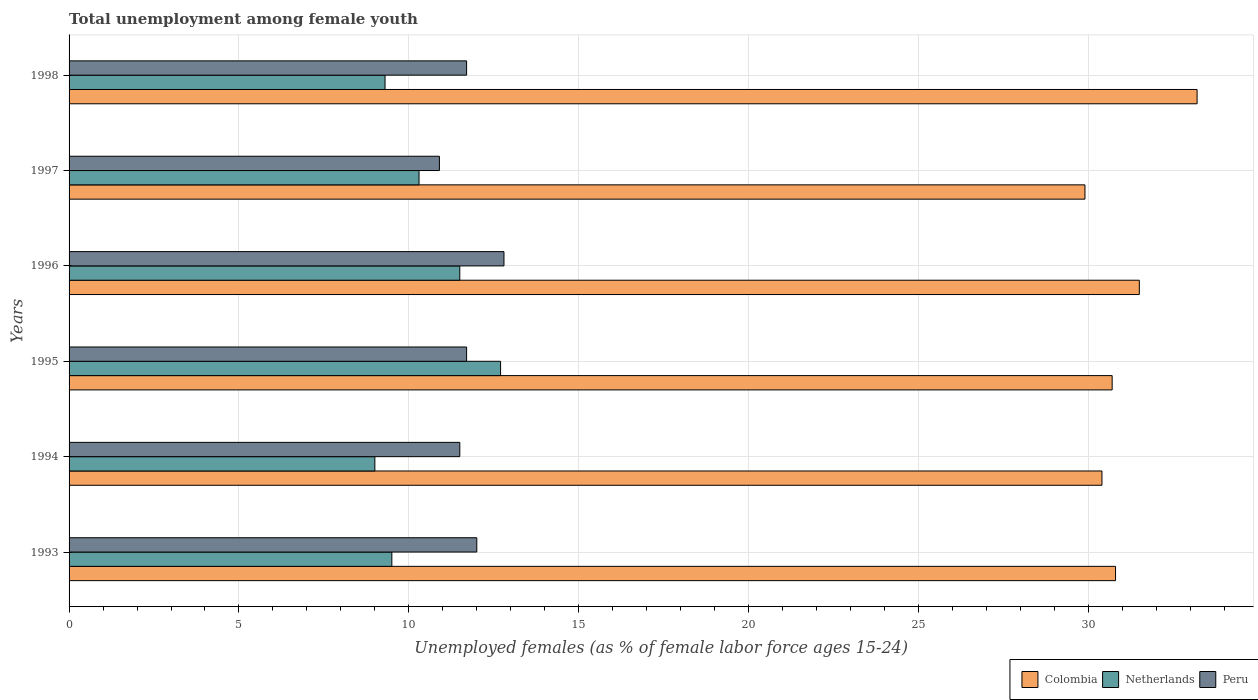How many different coloured bars are there?
Give a very brief answer. 3. Are the number of bars on each tick of the Y-axis equal?
Your answer should be very brief. Yes. How many bars are there on the 5th tick from the bottom?
Make the answer very short. 3. What is the percentage of unemployed females in in Peru in 1993?
Provide a succinct answer. 12. Across all years, what is the maximum percentage of unemployed females in in Colombia?
Provide a short and direct response. 33.2. Across all years, what is the minimum percentage of unemployed females in in Peru?
Offer a terse response. 10.9. In which year was the percentage of unemployed females in in Colombia minimum?
Your answer should be very brief. 1997. What is the total percentage of unemployed females in in Peru in the graph?
Offer a terse response. 70.6. What is the difference between the percentage of unemployed females in in Netherlands in 1994 and that in 1995?
Ensure brevity in your answer.  -3.7. What is the difference between the percentage of unemployed females in in Colombia in 1994 and the percentage of unemployed females in in Netherlands in 1995?
Your answer should be very brief. 17.7. What is the average percentage of unemployed females in in Colombia per year?
Offer a very short reply. 31.08. In the year 1997, what is the difference between the percentage of unemployed females in in Peru and percentage of unemployed females in in Colombia?
Your answer should be very brief. -19. What is the ratio of the percentage of unemployed females in in Netherlands in 1997 to that in 1998?
Ensure brevity in your answer.  1.11. Is the percentage of unemployed females in in Netherlands in 1995 less than that in 1996?
Your answer should be compact. No. Is the difference between the percentage of unemployed females in in Peru in 1995 and 1998 greater than the difference between the percentage of unemployed females in in Colombia in 1995 and 1998?
Make the answer very short. Yes. What is the difference between the highest and the second highest percentage of unemployed females in in Netherlands?
Ensure brevity in your answer.  1.2. What is the difference between the highest and the lowest percentage of unemployed females in in Colombia?
Make the answer very short. 3.3. In how many years, is the percentage of unemployed females in in Netherlands greater than the average percentage of unemployed females in in Netherlands taken over all years?
Your response must be concise. 2. Is the sum of the percentage of unemployed females in in Colombia in 1995 and 1997 greater than the maximum percentage of unemployed females in in Netherlands across all years?
Make the answer very short. Yes. Is it the case that in every year, the sum of the percentage of unemployed females in in Colombia and percentage of unemployed females in in Netherlands is greater than the percentage of unemployed females in in Peru?
Your answer should be very brief. Yes. How many bars are there?
Make the answer very short. 18. Are the values on the major ticks of X-axis written in scientific E-notation?
Your response must be concise. No. Does the graph contain grids?
Your answer should be compact. Yes. Where does the legend appear in the graph?
Provide a succinct answer. Bottom right. What is the title of the graph?
Give a very brief answer. Total unemployment among female youth. What is the label or title of the X-axis?
Your answer should be compact. Unemployed females (as % of female labor force ages 15-24). What is the label or title of the Y-axis?
Provide a short and direct response. Years. What is the Unemployed females (as % of female labor force ages 15-24) in Colombia in 1993?
Provide a short and direct response. 30.8. What is the Unemployed females (as % of female labor force ages 15-24) in Netherlands in 1993?
Give a very brief answer. 9.5. What is the Unemployed females (as % of female labor force ages 15-24) in Peru in 1993?
Provide a short and direct response. 12. What is the Unemployed females (as % of female labor force ages 15-24) of Colombia in 1994?
Offer a very short reply. 30.4. What is the Unemployed females (as % of female labor force ages 15-24) in Peru in 1994?
Ensure brevity in your answer.  11.5. What is the Unemployed females (as % of female labor force ages 15-24) of Colombia in 1995?
Give a very brief answer. 30.7. What is the Unemployed females (as % of female labor force ages 15-24) in Netherlands in 1995?
Your response must be concise. 12.7. What is the Unemployed females (as % of female labor force ages 15-24) in Peru in 1995?
Your answer should be compact. 11.7. What is the Unemployed females (as % of female labor force ages 15-24) in Colombia in 1996?
Ensure brevity in your answer.  31.5. What is the Unemployed females (as % of female labor force ages 15-24) of Netherlands in 1996?
Provide a short and direct response. 11.5. What is the Unemployed females (as % of female labor force ages 15-24) of Peru in 1996?
Keep it short and to the point. 12.8. What is the Unemployed females (as % of female labor force ages 15-24) of Colombia in 1997?
Your answer should be compact. 29.9. What is the Unemployed females (as % of female labor force ages 15-24) of Netherlands in 1997?
Your answer should be very brief. 10.3. What is the Unemployed females (as % of female labor force ages 15-24) of Peru in 1997?
Provide a short and direct response. 10.9. What is the Unemployed females (as % of female labor force ages 15-24) in Colombia in 1998?
Make the answer very short. 33.2. What is the Unemployed females (as % of female labor force ages 15-24) of Netherlands in 1998?
Give a very brief answer. 9.3. What is the Unemployed females (as % of female labor force ages 15-24) of Peru in 1998?
Keep it short and to the point. 11.7. Across all years, what is the maximum Unemployed females (as % of female labor force ages 15-24) of Colombia?
Your answer should be compact. 33.2. Across all years, what is the maximum Unemployed females (as % of female labor force ages 15-24) in Netherlands?
Your answer should be compact. 12.7. Across all years, what is the maximum Unemployed females (as % of female labor force ages 15-24) in Peru?
Offer a very short reply. 12.8. Across all years, what is the minimum Unemployed females (as % of female labor force ages 15-24) of Colombia?
Offer a terse response. 29.9. Across all years, what is the minimum Unemployed females (as % of female labor force ages 15-24) in Peru?
Your answer should be very brief. 10.9. What is the total Unemployed females (as % of female labor force ages 15-24) in Colombia in the graph?
Your answer should be compact. 186.5. What is the total Unemployed females (as % of female labor force ages 15-24) in Netherlands in the graph?
Your answer should be very brief. 62.3. What is the total Unemployed females (as % of female labor force ages 15-24) in Peru in the graph?
Ensure brevity in your answer.  70.6. What is the difference between the Unemployed females (as % of female labor force ages 15-24) in Colombia in 1993 and that in 1995?
Keep it short and to the point. 0.1. What is the difference between the Unemployed females (as % of female labor force ages 15-24) of Peru in 1993 and that in 1995?
Your answer should be very brief. 0.3. What is the difference between the Unemployed females (as % of female labor force ages 15-24) of Colombia in 1993 and that in 1996?
Offer a very short reply. -0.7. What is the difference between the Unemployed females (as % of female labor force ages 15-24) of Colombia in 1993 and that in 1997?
Offer a terse response. 0.9. What is the difference between the Unemployed females (as % of female labor force ages 15-24) of Colombia in 1993 and that in 1998?
Offer a very short reply. -2.4. What is the difference between the Unemployed females (as % of female labor force ages 15-24) in Netherlands in 1993 and that in 1998?
Your answer should be very brief. 0.2. What is the difference between the Unemployed females (as % of female labor force ages 15-24) of Peru in 1993 and that in 1998?
Offer a very short reply. 0.3. What is the difference between the Unemployed females (as % of female labor force ages 15-24) in Peru in 1994 and that in 1995?
Your answer should be compact. -0.2. What is the difference between the Unemployed females (as % of female labor force ages 15-24) in Colombia in 1994 and that in 1997?
Provide a short and direct response. 0.5. What is the difference between the Unemployed females (as % of female labor force ages 15-24) of Netherlands in 1994 and that in 1997?
Provide a short and direct response. -1.3. What is the difference between the Unemployed females (as % of female labor force ages 15-24) of Peru in 1994 and that in 1997?
Your answer should be very brief. 0.6. What is the difference between the Unemployed females (as % of female labor force ages 15-24) of Netherlands in 1994 and that in 1998?
Offer a terse response. -0.3. What is the difference between the Unemployed females (as % of female labor force ages 15-24) of Peru in 1994 and that in 1998?
Your answer should be very brief. -0.2. What is the difference between the Unemployed females (as % of female labor force ages 15-24) in Netherlands in 1995 and that in 1996?
Keep it short and to the point. 1.2. What is the difference between the Unemployed females (as % of female labor force ages 15-24) of Peru in 1995 and that in 1996?
Your answer should be compact. -1.1. What is the difference between the Unemployed females (as % of female labor force ages 15-24) of Colombia in 1995 and that in 1997?
Ensure brevity in your answer.  0.8. What is the difference between the Unemployed females (as % of female labor force ages 15-24) of Colombia in 1995 and that in 1998?
Your answer should be compact. -2.5. What is the difference between the Unemployed females (as % of female labor force ages 15-24) in Colombia in 1996 and that in 1997?
Your answer should be compact. 1.6. What is the difference between the Unemployed females (as % of female labor force ages 15-24) in Peru in 1996 and that in 1997?
Give a very brief answer. 1.9. What is the difference between the Unemployed females (as % of female labor force ages 15-24) of Colombia in 1996 and that in 1998?
Provide a short and direct response. -1.7. What is the difference between the Unemployed females (as % of female labor force ages 15-24) of Peru in 1996 and that in 1998?
Offer a terse response. 1.1. What is the difference between the Unemployed females (as % of female labor force ages 15-24) of Colombia in 1997 and that in 1998?
Make the answer very short. -3.3. What is the difference between the Unemployed females (as % of female labor force ages 15-24) in Netherlands in 1997 and that in 1998?
Your answer should be compact. 1. What is the difference between the Unemployed females (as % of female labor force ages 15-24) in Peru in 1997 and that in 1998?
Offer a very short reply. -0.8. What is the difference between the Unemployed females (as % of female labor force ages 15-24) of Colombia in 1993 and the Unemployed females (as % of female labor force ages 15-24) of Netherlands in 1994?
Make the answer very short. 21.8. What is the difference between the Unemployed females (as % of female labor force ages 15-24) in Colombia in 1993 and the Unemployed females (as % of female labor force ages 15-24) in Peru in 1994?
Your answer should be very brief. 19.3. What is the difference between the Unemployed females (as % of female labor force ages 15-24) in Colombia in 1993 and the Unemployed females (as % of female labor force ages 15-24) in Peru in 1995?
Offer a very short reply. 19.1. What is the difference between the Unemployed females (as % of female labor force ages 15-24) of Colombia in 1993 and the Unemployed females (as % of female labor force ages 15-24) of Netherlands in 1996?
Your answer should be very brief. 19.3. What is the difference between the Unemployed females (as % of female labor force ages 15-24) of Colombia in 1993 and the Unemployed females (as % of female labor force ages 15-24) of Peru in 1996?
Keep it short and to the point. 18. What is the difference between the Unemployed females (as % of female labor force ages 15-24) of Colombia in 1993 and the Unemployed females (as % of female labor force ages 15-24) of Peru in 1998?
Your response must be concise. 19.1. What is the difference between the Unemployed females (as % of female labor force ages 15-24) of Netherlands in 1993 and the Unemployed females (as % of female labor force ages 15-24) of Peru in 1998?
Provide a succinct answer. -2.2. What is the difference between the Unemployed females (as % of female labor force ages 15-24) in Colombia in 1994 and the Unemployed females (as % of female labor force ages 15-24) in Netherlands in 1995?
Your response must be concise. 17.7. What is the difference between the Unemployed females (as % of female labor force ages 15-24) in Colombia in 1994 and the Unemployed females (as % of female labor force ages 15-24) in Peru in 1995?
Your answer should be compact. 18.7. What is the difference between the Unemployed females (as % of female labor force ages 15-24) in Colombia in 1994 and the Unemployed females (as % of female labor force ages 15-24) in Netherlands in 1996?
Provide a short and direct response. 18.9. What is the difference between the Unemployed females (as % of female labor force ages 15-24) of Netherlands in 1994 and the Unemployed females (as % of female labor force ages 15-24) of Peru in 1996?
Ensure brevity in your answer.  -3.8. What is the difference between the Unemployed females (as % of female labor force ages 15-24) of Colombia in 1994 and the Unemployed females (as % of female labor force ages 15-24) of Netherlands in 1997?
Offer a very short reply. 20.1. What is the difference between the Unemployed females (as % of female labor force ages 15-24) in Netherlands in 1994 and the Unemployed females (as % of female labor force ages 15-24) in Peru in 1997?
Offer a terse response. -1.9. What is the difference between the Unemployed females (as % of female labor force ages 15-24) of Colombia in 1994 and the Unemployed females (as % of female labor force ages 15-24) of Netherlands in 1998?
Give a very brief answer. 21.1. What is the difference between the Unemployed females (as % of female labor force ages 15-24) in Netherlands in 1994 and the Unemployed females (as % of female labor force ages 15-24) in Peru in 1998?
Your response must be concise. -2.7. What is the difference between the Unemployed females (as % of female labor force ages 15-24) in Colombia in 1995 and the Unemployed females (as % of female labor force ages 15-24) in Netherlands in 1996?
Offer a very short reply. 19.2. What is the difference between the Unemployed females (as % of female labor force ages 15-24) of Netherlands in 1995 and the Unemployed females (as % of female labor force ages 15-24) of Peru in 1996?
Ensure brevity in your answer.  -0.1. What is the difference between the Unemployed females (as % of female labor force ages 15-24) in Colombia in 1995 and the Unemployed females (as % of female labor force ages 15-24) in Netherlands in 1997?
Offer a very short reply. 20.4. What is the difference between the Unemployed females (as % of female labor force ages 15-24) of Colombia in 1995 and the Unemployed females (as % of female labor force ages 15-24) of Peru in 1997?
Offer a terse response. 19.8. What is the difference between the Unemployed females (as % of female labor force ages 15-24) in Netherlands in 1995 and the Unemployed females (as % of female labor force ages 15-24) in Peru in 1997?
Provide a short and direct response. 1.8. What is the difference between the Unemployed females (as % of female labor force ages 15-24) in Colombia in 1995 and the Unemployed females (as % of female labor force ages 15-24) in Netherlands in 1998?
Your response must be concise. 21.4. What is the difference between the Unemployed females (as % of female labor force ages 15-24) in Colombia in 1995 and the Unemployed females (as % of female labor force ages 15-24) in Peru in 1998?
Offer a terse response. 19. What is the difference between the Unemployed females (as % of female labor force ages 15-24) in Netherlands in 1995 and the Unemployed females (as % of female labor force ages 15-24) in Peru in 1998?
Provide a short and direct response. 1. What is the difference between the Unemployed females (as % of female labor force ages 15-24) of Colombia in 1996 and the Unemployed females (as % of female labor force ages 15-24) of Netherlands in 1997?
Your answer should be compact. 21.2. What is the difference between the Unemployed females (as % of female labor force ages 15-24) of Colombia in 1996 and the Unemployed females (as % of female labor force ages 15-24) of Peru in 1997?
Your answer should be compact. 20.6. What is the difference between the Unemployed females (as % of female labor force ages 15-24) of Colombia in 1996 and the Unemployed females (as % of female labor force ages 15-24) of Peru in 1998?
Your answer should be compact. 19.8. What is the difference between the Unemployed females (as % of female labor force ages 15-24) of Netherlands in 1996 and the Unemployed females (as % of female labor force ages 15-24) of Peru in 1998?
Ensure brevity in your answer.  -0.2. What is the difference between the Unemployed females (as % of female labor force ages 15-24) in Colombia in 1997 and the Unemployed females (as % of female labor force ages 15-24) in Netherlands in 1998?
Make the answer very short. 20.6. What is the difference between the Unemployed females (as % of female labor force ages 15-24) in Colombia in 1997 and the Unemployed females (as % of female labor force ages 15-24) in Peru in 1998?
Provide a short and direct response. 18.2. What is the difference between the Unemployed females (as % of female labor force ages 15-24) of Netherlands in 1997 and the Unemployed females (as % of female labor force ages 15-24) of Peru in 1998?
Your answer should be compact. -1.4. What is the average Unemployed females (as % of female labor force ages 15-24) of Colombia per year?
Your answer should be very brief. 31.08. What is the average Unemployed females (as % of female labor force ages 15-24) of Netherlands per year?
Keep it short and to the point. 10.38. What is the average Unemployed females (as % of female labor force ages 15-24) in Peru per year?
Ensure brevity in your answer.  11.77. In the year 1993, what is the difference between the Unemployed females (as % of female labor force ages 15-24) in Colombia and Unemployed females (as % of female labor force ages 15-24) in Netherlands?
Your answer should be very brief. 21.3. In the year 1993, what is the difference between the Unemployed females (as % of female labor force ages 15-24) in Colombia and Unemployed females (as % of female labor force ages 15-24) in Peru?
Make the answer very short. 18.8. In the year 1993, what is the difference between the Unemployed females (as % of female labor force ages 15-24) in Netherlands and Unemployed females (as % of female labor force ages 15-24) in Peru?
Your answer should be compact. -2.5. In the year 1994, what is the difference between the Unemployed females (as % of female labor force ages 15-24) in Colombia and Unemployed females (as % of female labor force ages 15-24) in Netherlands?
Provide a short and direct response. 21.4. In the year 1994, what is the difference between the Unemployed females (as % of female labor force ages 15-24) in Colombia and Unemployed females (as % of female labor force ages 15-24) in Peru?
Offer a terse response. 18.9. In the year 1994, what is the difference between the Unemployed females (as % of female labor force ages 15-24) of Netherlands and Unemployed females (as % of female labor force ages 15-24) of Peru?
Provide a short and direct response. -2.5. In the year 1995, what is the difference between the Unemployed females (as % of female labor force ages 15-24) in Colombia and Unemployed females (as % of female labor force ages 15-24) in Peru?
Provide a short and direct response. 19. In the year 1996, what is the difference between the Unemployed females (as % of female labor force ages 15-24) of Colombia and Unemployed females (as % of female labor force ages 15-24) of Peru?
Your answer should be very brief. 18.7. In the year 1996, what is the difference between the Unemployed females (as % of female labor force ages 15-24) of Netherlands and Unemployed females (as % of female labor force ages 15-24) of Peru?
Your answer should be very brief. -1.3. In the year 1997, what is the difference between the Unemployed females (as % of female labor force ages 15-24) of Colombia and Unemployed females (as % of female labor force ages 15-24) of Netherlands?
Your response must be concise. 19.6. In the year 1997, what is the difference between the Unemployed females (as % of female labor force ages 15-24) of Colombia and Unemployed females (as % of female labor force ages 15-24) of Peru?
Give a very brief answer. 19. In the year 1997, what is the difference between the Unemployed females (as % of female labor force ages 15-24) of Netherlands and Unemployed females (as % of female labor force ages 15-24) of Peru?
Provide a succinct answer. -0.6. In the year 1998, what is the difference between the Unemployed females (as % of female labor force ages 15-24) of Colombia and Unemployed females (as % of female labor force ages 15-24) of Netherlands?
Your answer should be compact. 23.9. In the year 1998, what is the difference between the Unemployed females (as % of female labor force ages 15-24) of Colombia and Unemployed females (as % of female labor force ages 15-24) of Peru?
Provide a short and direct response. 21.5. In the year 1998, what is the difference between the Unemployed females (as % of female labor force ages 15-24) of Netherlands and Unemployed females (as % of female labor force ages 15-24) of Peru?
Make the answer very short. -2.4. What is the ratio of the Unemployed females (as % of female labor force ages 15-24) of Colombia in 1993 to that in 1994?
Give a very brief answer. 1.01. What is the ratio of the Unemployed females (as % of female labor force ages 15-24) of Netherlands in 1993 to that in 1994?
Offer a terse response. 1.06. What is the ratio of the Unemployed females (as % of female labor force ages 15-24) of Peru in 1993 to that in 1994?
Your answer should be very brief. 1.04. What is the ratio of the Unemployed females (as % of female labor force ages 15-24) in Netherlands in 1993 to that in 1995?
Provide a short and direct response. 0.75. What is the ratio of the Unemployed females (as % of female labor force ages 15-24) in Peru in 1993 to that in 1995?
Provide a short and direct response. 1.03. What is the ratio of the Unemployed females (as % of female labor force ages 15-24) in Colombia in 1993 to that in 1996?
Your response must be concise. 0.98. What is the ratio of the Unemployed females (as % of female labor force ages 15-24) of Netherlands in 1993 to that in 1996?
Ensure brevity in your answer.  0.83. What is the ratio of the Unemployed females (as % of female labor force ages 15-24) in Peru in 1993 to that in 1996?
Make the answer very short. 0.94. What is the ratio of the Unemployed females (as % of female labor force ages 15-24) of Colombia in 1993 to that in 1997?
Ensure brevity in your answer.  1.03. What is the ratio of the Unemployed females (as % of female labor force ages 15-24) of Netherlands in 1993 to that in 1997?
Provide a succinct answer. 0.92. What is the ratio of the Unemployed females (as % of female labor force ages 15-24) in Peru in 1993 to that in 1997?
Keep it short and to the point. 1.1. What is the ratio of the Unemployed females (as % of female labor force ages 15-24) in Colombia in 1993 to that in 1998?
Give a very brief answer. 0.93. What is the ratio of the Unemployed females (as % of female labor force ages 15-24) in Netherlands in 1993 to that in 1998?
Your answer should be compact. 1.02. What is the ratio of the Unemployed females (as % of female labor force ages 15-24) of Peru in 1993 to that in 1998?
Your answer should be very brief. 1.03. What is the ratio of the Unemployed females (as % of female labor force ages 15-24) in Colombia in 1994 to that in 1995?
Your answer should be compact. 0.99. What is the ratio of the Unemployed females (as % of female labor force ages 15-24) of Netherlands in 1994 to that in 1995?
Your response must be concise. 0.71. What is the ratio of the Unemployed females (as % of female labor force ages 15-24) of Peru in 1994 to that in 1995?
Offer a very short reply. 0.98. What is the ratio of the Unemployed females (as % of female labor force ages 15-24) in Colombia in 1994 to that in 1996?
Provide a short and direct response. 0.97. What is the ratio of the Unemployed females (as % of female labor force ages 15-24) in Netherlands in 1994 to that in 1996?
Provide a short and direct response. 0.78. What is the ratio of the Unemployed females (as % of female labor force ages 15-24) in Peru in 1994 to that in 1996?
Offer a very short reply. 0.9. What is the ratio of the Unemployed females (as % of female labor force ages 15-24) in Colombia in 1994 to that in 1997?
Make the answer very short. 1.02. What is the ratio of the Unemployed females (as % of female labor force ages 15-24) in Netherlands in 1994 to that in 1997?
Your response must be concise. 0.87. What is the ratio of the Unemployed females (as % of female labor force ages 15-24) of Peru in 1994 to that in 1997?
Offer a very short reply. 1.05. What is the ratio of the Unemployed females (as % of female labor force ages 15-24) of Colombia in 1994 to that in 1998?
Ensure brevity in your answer.  0.92. What is the ratio of the Unemployed females (as % of female labor force ages 15-24) of Netherlands in 1994 to that in 1998?
Ensure brevity in your answer.  0.97. What is the ratio of the Unemployed females (as % of female labor force ages 15-24) in Peru in 1994 to that in 1998?
Offer a very short reply. 0.98. What is the ratio of the Unemployed females (as % of female labor force ages 15-24) of Colombia in 1995 to that in 1996?
Your response must be concise. 0.97. What is the ratio of the Unemployed females (as % of female labor force ages 15-24) in Netherlands in 1995 to that in 1996?
Make the answer very short. 1.1. What is the ratio of the Unemployed females (as % of female labor force ages 15-24) in Peru in 1995 to that in 1996?
Your answer should be very brief. 0.91. What is the ratio of the Unemployed females (as % of female labor force ages 15-24) in Colombia in 1995 to that in 1997?
Offer a very short reply. 1.03. What is the ratio of the Unemployed females (as % of female labor force ages 15-24) of Netherlands in 1995 to that in 1997?
Ensure brevity in your answer.  1.23. What is the ratio of the Unemployed females (as % of female labor force ages 15-24) of Peru in 1995 to that in 1997?
Provide a succinct answer. 1.07. What is the ratio of the Unemployed females (as % of female labor force ages 15-24) in Colombia in 1995 to that in 1998?
Provide a succinct answer. 0.92. What is the ratio of the Unemployed females (as % of female labor force ages 15-24) of Netherlands in 1995 to that in 1998?
Ensure brevity in your answer.  1.37. What is the ratio of the Unemployed females (as % of female labor force ages 15-24) in Colombia in 1996 to that in 1997?
Your response must be concise. 1.05. What is the ratio of the Unemployed females (as % of female labor force ages 15-24) in Netherlands in 1996 to that in 1997?
Provide a short and direct response. 1.12. What is the ratio of the Unemployed females (as % of female labor force ages 15-24) in Peru in 1996 to that in 1997?
Give a very brief answer. 1.17. What is the ratio of the Unemployed females (as % of female labor force ages 15-24) of Colombia in 1996 to that in 1998?
Ensure brevity in your answer.  0.95. What is the ratio of the Unemployed females (as % of female labor force ages 15-24) of Netherlands in 1996 to that in 1998?
Your answer should be compact. 1.24. What is the ratio of the Unemployed females (as % of female labor force ages 15-24) of Peru in 1996 to that in 1998?
Provide a succinct answer. 1.09. What is the ratio of the Unemployed females (as % of female labor force ages 15-24) of Colombia in 1997 to that in 1998?
Offer a very short reply. 0.9. What is the ratio of the Unemployed females (as % of female labor force ages 15-24) in Netherlands in 1997 to that in 1998?
Ensure brevity in your answer.  1.11. What is the ratio of the Unemployed females (as % of female labor force ages 15-24) of Peru in 1997 to that in 1998?
Provide a short and direct response. 0.93. What is the difference between the highest and the second highest Unemployed females (as % of female labor force ages 15-24) in Peru?
Offer a terse response. 0.8. What is the difference between the highest and the lowest Unemployed females (as % of female labor force ages 15-24) of Netherlands?
Your response must be concise. 3.7. What is the difference between the highest and the lowest Unemployed females (as % of female labor force ages 15-24) of Peru?
Offer a very short reply. 1.9. 